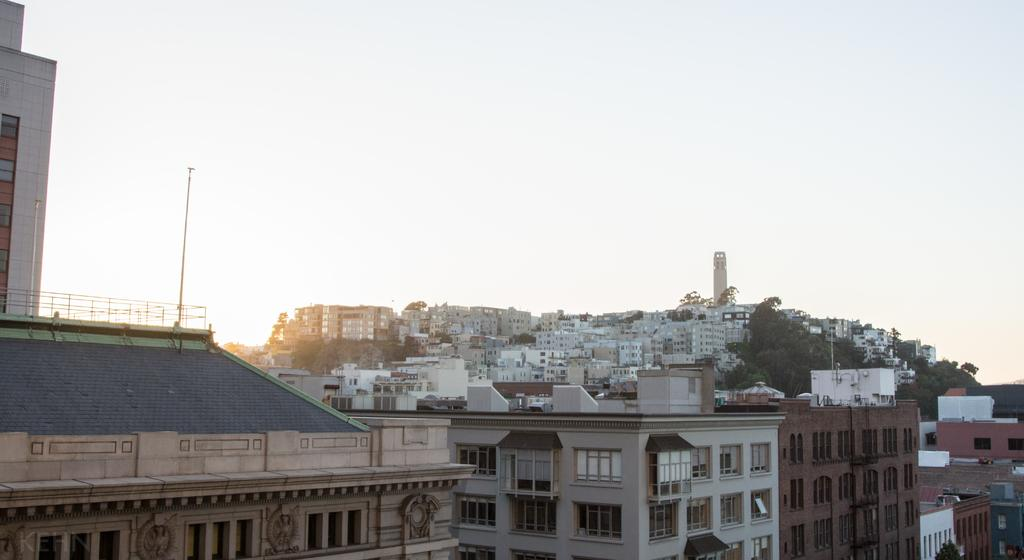What type of structures can be seen in the image? There are buildings in the image. What else is present in the image besides buildings? There are poles and trees in the image. What can be seen in the background of the image? The sky is visible in the image. What type of sugar is being used to sweeten the gun in the image? There is no gun or sugar present in the image. 